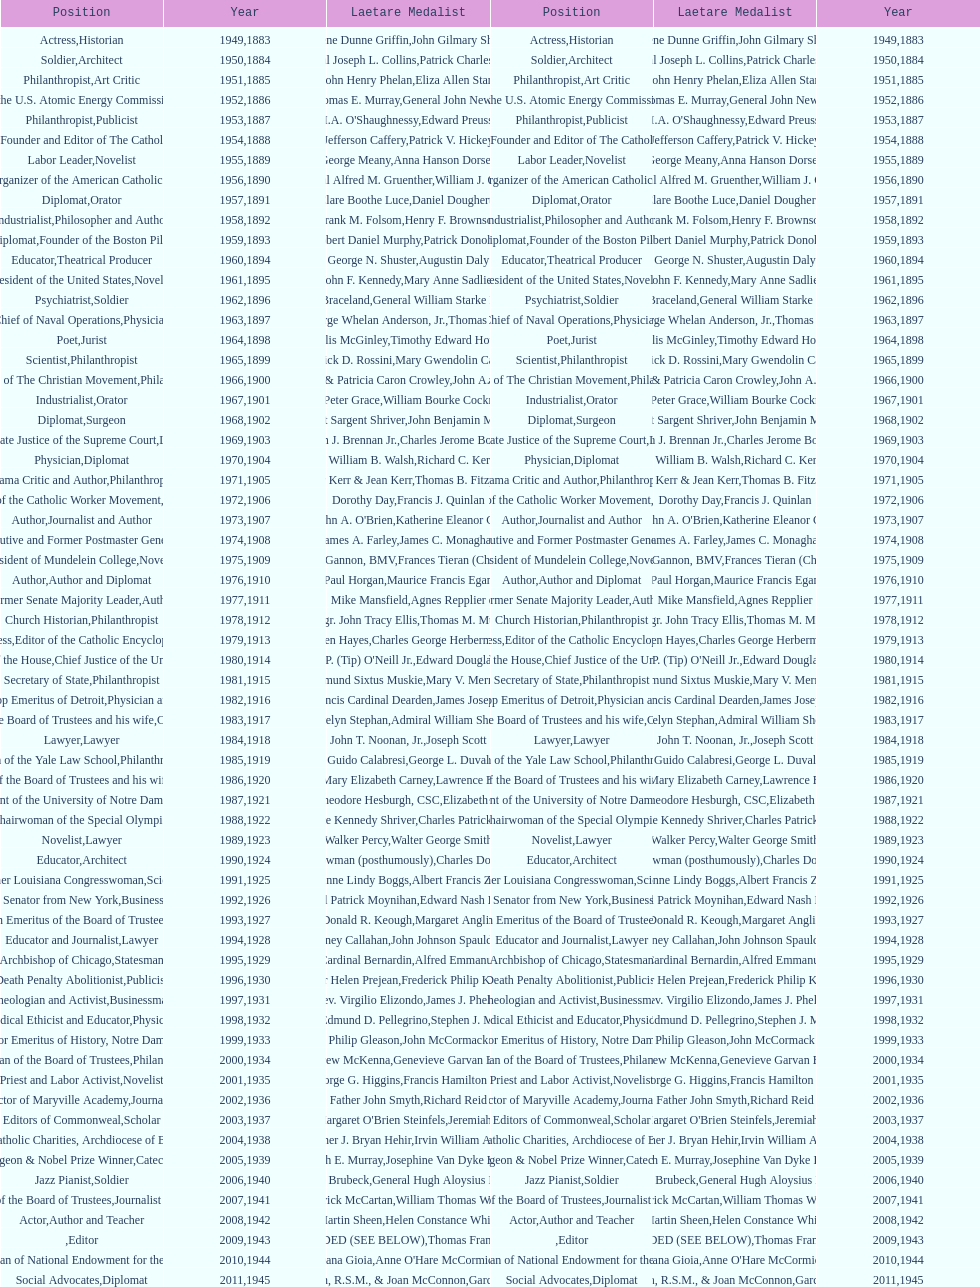How many times does philanthropist appear in the position column on this chart? 9. 